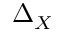<formula> <loc_0><loc_0><loc_500><loc_500>\Delta _ { X }</formula> 